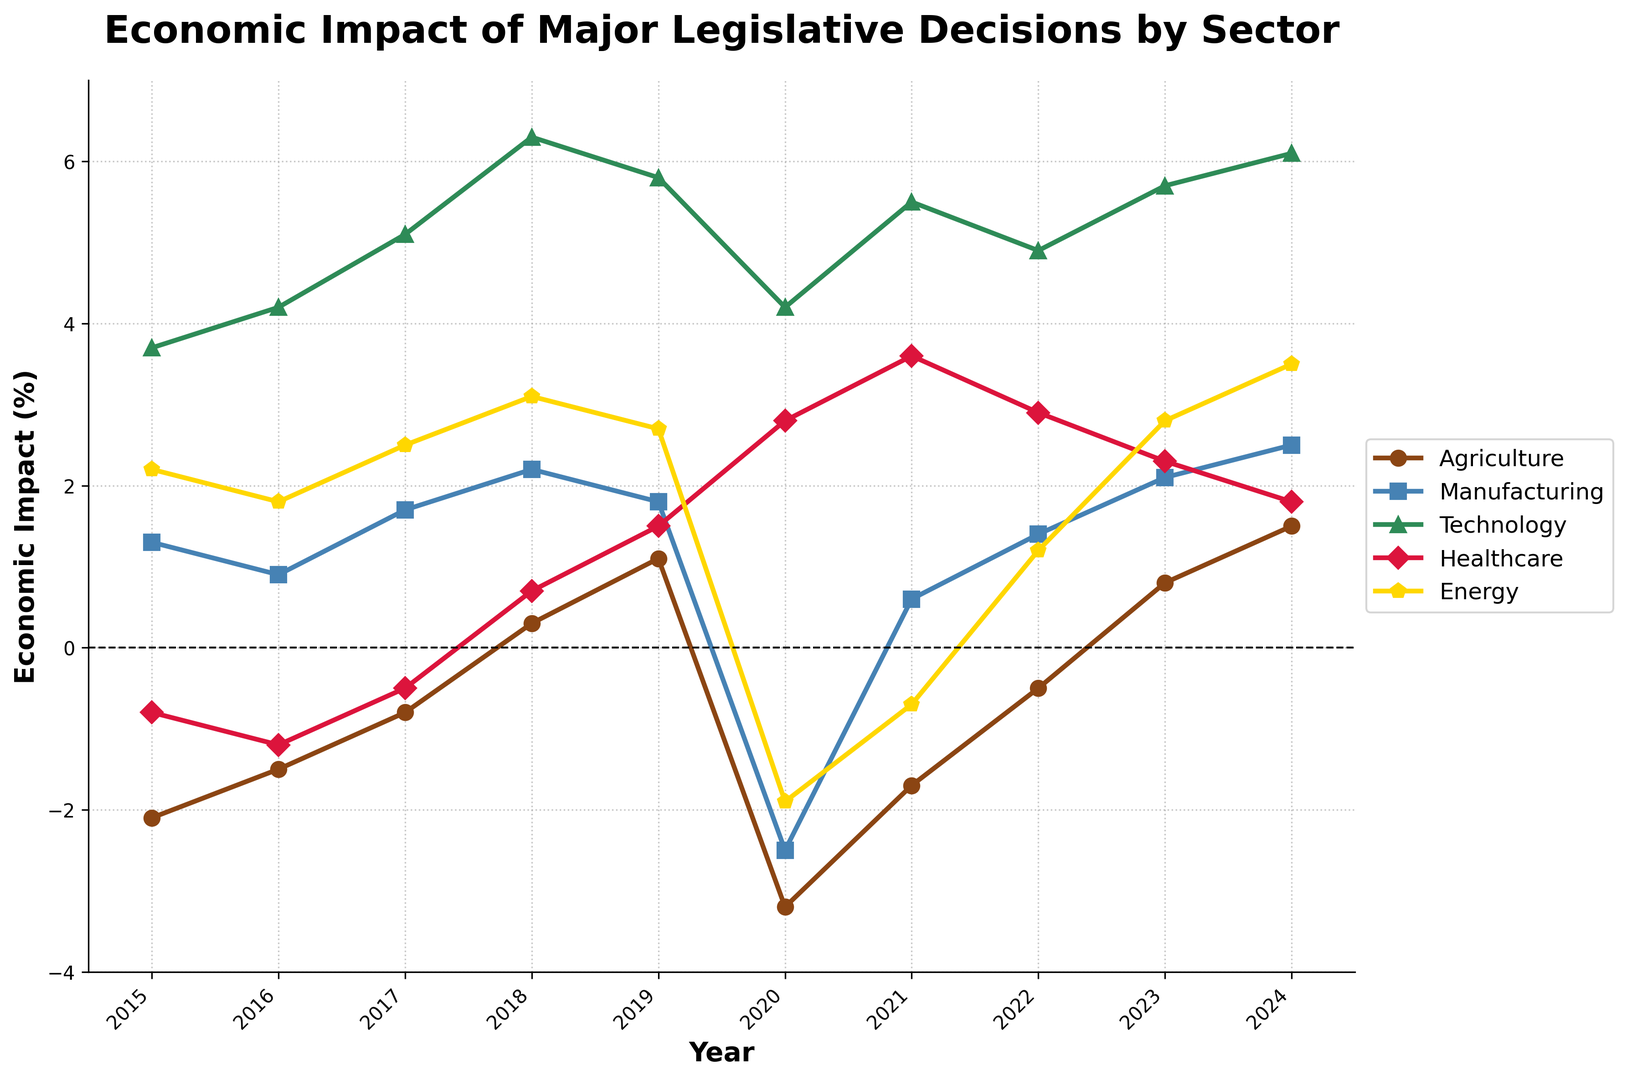What's the overall trend for the Technology sector from 2015 to 2024? To determine the overall trend for the Technology sector, look at the values corresponding to each year from 2015 to 2024. The values continuously increase from 3.7% in 2015 to 6.1% in 2024, which shows a positive upward trend.
Answer: Upward trend Which sector experienced the largest negative impact in 2020, and by how much? Examine the values for each sector in 2020. The Agriculture sector shows the largest negative impact with a value of -3.2%.
Answer: Agriculture, -3.2% In which year did the Healthcare sector change from a negative impact to a positive impact? Track the values of the Healthcare sector over the years. The Healthcare sector changed from -0.8% in 2015 to 0.7% in 2018, which shows the first positive value.
Answer: 2018 Which sector has the least volatility in the given period, and how did you determine it? Calculate the range (max value - min value) for each sector. The sector with the smallest range has the least volatility. Values are -1.8% to 2.5% for Manufacturing (range 4.3%), which is the smallest compared to other sectors.
Answer: Manufacturing, range 4.3% What's the average economic impact on Agriculture from 2015 to 2024? Sum up the percentages for Agriculture from 2015 to 2024 and divide by the number of years (10). (−2.1 + −1.5 + −0.8 + 0.3 + 1.1 + -3.2 + -1.7 + -0.5 + 0.8 + 1.5) / 10 = −0.71%.
Answer: -0.71% How did the impact on Manufacturing in 2023 compare to the impact on Energy in the same year? Check the values for both sectors in 2023. Manufacturing is 2.1% and Energy is 2.8%. Manufacturing is less than Energy by 0.7%.
Answer: Manufacturing is 0.7% less than Energy Which sectors experienced a consistently positive impact every year from 2018 to 2024? Look at the values for each sector from 2018 to 2024. Technology and Healthcare have consistently positive values in every year within this range.
Answer: Technology, Healthcare In which year did all sectors experience gains? Review the chart for each year to see if all values are positive. Only in 2024 do all sectors show positive values.
Answer: 2024 How does the trend of the Energy sector compare to that of the Manufacturing sector from 2015 to 2024? Compare the lines of Energy and Manufacturing. The Manufacturing sector shows a general upward trend, while the Energy sector has a fluctuating trend with significant drops in 2020 and 2021, before rising again.
Answer: Manufacturing has a more consistent upward trend; Energy fluctuates 